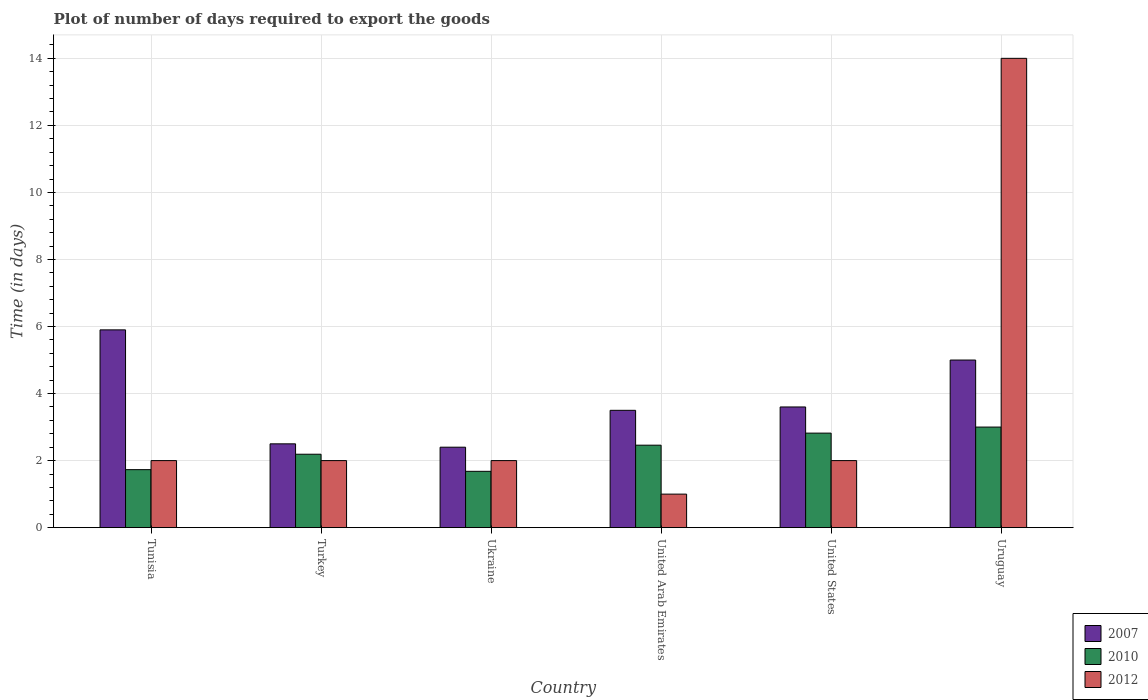How many groups of bars are there?
Offer a terse response. 6. Are the number of bars per tick equal to the number of legend labels?
Keep it short and to the point. Yes. Are the number of bars on each tick of the X-axis equal?
Your response must be concise. Yes. How many bars are there on the 4th tick from the left?
Provide a succinct answer. 3. How many bars are there on the 4th tick from the right?
Provide a succinct answer. 3. What is the label of the 4th group of bars from the left?
Give a very brief answer. United Arab Emirates. In how many cases, is the number of bars for a given country not equal to the number of legend labels?
Your answer should be compact. 0. What is the time required to export goods in 2010 in United States?
Offer a terse response. 2.82. Across all countries, what is the maximum time required to export goods in 2012?
Your answer should be compact. 14. Across all countries, what is the minimum time required to export goods in 2010?
Provide a short and direct response. 1.68. In which country was the time required to export goods in 2007 maximum?
Keep it short and to the point. Tunisia. In which country was the time required to export goods in 2010 minimum?
Offer a terse response. Ukraine. What is the total time required to export goods in 2010 in the graph?
Your answer should be very brief. 13.88. What is the difference between the time required to export goods in 2010 in Ukraine and that in United Arab Emirates?
Keep it short and to the point. -0.78. What is the difference between the time required to export goods in 2010 in Tunisia and the time required to export goods in 2012 in United States?
Your answer should be compact. -0.27. What is the average time required to export goods in 2012 per country?
Make the answer very short. 3.83. What is the difference between the time required to export goods of/in 2007 and time required to export goods of/in 2012 in Ukraine?
Provide a succinct answer. 0.4. What is the ratio of the time required to export goods in 2012 in Ukraine to that in United Arab Emirates?
Your response must be concise. 2. Is the difference between the time required to export goods in 2007 in Tunisia and Turkey greater than the difference between the time required to export goods in 2012 in Tunisia and Turkey?
Provide a succinct answer. Yes. What is the difference between the highest and the lowest time required to export goods in 2007?
Keep it short and to the point. 3.5. In how many countries, is the time required to export goods in 2010 greater than the average time required to export goods in 2010 taken over all countries?
Provide a succinct answer. 3. Is the sum of the time required to export goods in 2012 in Tunisia and United States greater than the maximum time required to export goods in 2007 across all countries?
Give a very brief answer. No. What does the 3rd bar from the left in United States represents?
Keep it short and to the point. 2012. Is it the case that in every country, the sum of the time required to export goods in 2010 and time required to export goods in 2012 is greater than the time required to export goods in 2007?
Provide a succinct answer. No. Are all the bars in the graph horizontal?
Keep it short and to the point. No. What is the difference between two consecutive major ticks on the Y-axis?
Your answer should be compact. 2. Are the values on the major ticks of Y-axis written in scientific E-notation?
Your response must be concise. No. Does the graph contain any zero values?
Offer a terse response. No. Does the graph contain grids?
Your answer should be compact. Yes. Where does the legend appear in the graph?
Your answer should be very brief. Bottom right. How many legend labels are there?
Make the answer very short. 3. How are the legend labels stacked?
Provide a short and direct response. Vertical. What is the title of the graph?
Ensure brevity in your answer.  Plot of number of days required to export the goods. What is the label or title of the X-axis?
Offer a very short reply. Country. What is the label or title of the Y-axis?
Offer a very short reply. Time (in days). What is the Time (in days) in 2010 in Tunisia?
Offer a very short reply. 1.73. What is the Time (in days) of 2010 in Turkey?
Provide a short and direct response. 2.19. What is the Time (in days) in 2012 in Turkey?
Give a very brief answer. 2. What is the Time (in days) in 2010 in Ukraine?
Give a very brief answer. 1.68. What is the Time (in days) in 2012 in Ukraine?
Keep it short and to the point. 2. What is the Time (in days) in 2010 in United Arab Emirates?
Keep it short and to the point. 2.46. What is the Time (in days) of 2012 in United Arab Emirates?
Make the answer very short. 1. What is the Time (in days) of 2010 in United States?
Your response must be concise. 2.82. What is the Time (in days) in 2007 in Uruguay?
Your answer should be compact. 5. What is the Time (in days) of 2010 in Uruguay?
Keep it short and to the point. 3. Across all countries, what is the maximum Time (in days) of 2010?
Your answer should be very brief. 3. Across all countries, what is the maximum Time (in days) of 2012?
Your response must be concise. 14. Across all countries, what is the minimum Time (in days) in 2007?
Give a very brief answer. 2.4. Across all countries, what is the minimum Time (in days) in 2010?
Provide a succinct answer. 1.68. What is the total Time (in days) in 2007 in the graph?
Keep it short and to the point. 22.9. What is the total Time (in days) in 2010 in the graph?
Make the answer very short. 13.88. What is the difference between the Time (in days) in 2010 in Tunisia and that in Turkey?
Ensure brevity in your answer.  -0.46. What is the difference between the Time (in days) of 2012 in Tunisia and that in Turkey?
Give a very brief answer. 0. What is the difference between the Time (in days) in 2007 in Tunisia and that in Ukraine?
Your answer should be very brief. 3.5. What is the difference between the Time (in days) of 2010 in Tunisia and that in Ukraine?
Give a very brief answer. 0.05. What is the difference between the Time (in days) of 2007 in Tunisia and that in United Arab Emirates?
Offer a very short reply. 2.4. What is the difference between the Time (in days) in 2010 in Tunisia and that in United Arab Emirates?
Keep it short and to the point. -0.73. What is the difference between the Time (in days) in 2010 in Tunisia and that in United States?
Your answer should be compact. -1.09. What is the difference between the Time (in days) of 2012 in Tunisia and that in United States?
Provide a succinct answer. 0. What is the difference between the Time (in days) in 2007 in Tunisia and that in Uruguay?
Your response must be concise. 0.9. What is the difference between the Time (in days) in 2010 in Tunisia and that in Uruguay?
Your answer should be compact. -1.27. What is the difference between the Time (in days) of 2007 in Turkey and that in Ukraine?
Offer a very short reply. 0.1. What is the difference between the Time (in days) of 2010 in Turkey and that in Ukraine?
Your answer should be very brief. 0.51. What is the difference between the Time (in days) of 2010 in Turkey and that in United Arab Emirates?
Your answer should be compact. -0.27. What is the difference between the Time (in days) in 2012 in Turkey and that in United Arab Emirates?
Provide a succinct answer. 1. What is the difference between the Time (in days) in 2007 in Turkey and that in United States?
Offer a terse response. -1.1. What is the difference between the Time (in days) in 2010 in Turkey and that in United States?
Ensure brevity in your answer.  -0.63. What is the difference between the Time (in days) in 2012 in Turkey and that in United States?
Offer a very short reply. 0. What is the difference between the Time (in days) of 2007 in Turkey and that in Uruguay?
Give a very brief answer. -2.5. What is the difference between the Time (in days) of 2010 in Turkey and that in Uruguay?
Offer a very short reply. -0.81. What is the difference between the Time (in days) in 2010 in Ukraine and that in United Arab Emirates?
Make the answer very short. -0.78. What is the difference between the Time (in days) of 2012 in Ukraine and that in United Arab Emirates?
Provide a succinct answer. 1. What is the difference between the Time (in days) of 2010 in Ukraine and that in United States?
Offer a terse response. -1.14. What is the difference between the Time (in days) in 2007 in Ukraine and that in Uruguay?
Your answer should be very brief. -2.6. What is the difference between the Time (in days) of 2010 in Ukraine and that in Uruguay?
Your response must be concise. -1.32. What is the difference between the Time (in days) of 2007 in United Arab Emirates and that in United States?
Provide a succinct answer. -0.1. What is the difference between the Time (in days) of 2010 in United Arab Emirates and that in United States?
Offer a very short reply. -0.36. What is the difference between the Time (in days) of 2010 in United Arab Emirates and that in Uruguay?
Your answer should be compact. -0.54. What is the difference between the Time (in days) in 2012 in United Arab Emirates and that in Uruguay?
Give a very brief answer. -13. What is the difference between the Time (in days) of 2010 in United States and that in Uruguay?
Ensure brevity in your answer.  -0.18. What is the difference between the Time (in days) of 2012 in United States and that in Uruguay?
Give a very brief answer. -12. What is the difference between the Time (in days) of 2007 in Tunisia and the Time (in days) of 2010 in Turkey?
Provide a short and direct response. 3.71. What is the difference between the Time (in days) in 2010 in Tunisia and the Time (in days) in 2012 in Turkey?
Your answer should be very brief. -0.27. What is the difference between the Time (in days) of 2007 in Tunisia and the Time (in days) of 2010 in Ukraine?
Make the answer very short. 4.22. What is the difference between the Time (in days) of 2010 in Tunisia and the Time (in days) of 2012 in Ukraine?
Make the answer very short. -0.27. What is the difference between the Time (in days) in 2007 in Tunisia and the Time (in days) in 2010 in United Arab Emirates?
Your answer should be compact. 3.44. What is the difference between the Time (in days) of 2010 in Tunisia and the Time (in days) of 2012 in United Arab Emirates?
Your response must be concise. 0.73. What is the difference between the Time (in days) of 2007 in Tunisia and the Time (in days) of 2010 in United States?
Your answer should be compact. 3.08. What is the difference between the Time (in days) in 2010 in Tunisia and the Time (in days) in 2012 in United States?
Ensure brevity in your answer.  -0.27. What is the difference between the Time (in days) in 2007 in Tunisia and the Time (in days) in 2010 in Uruguay?
Provide a succinct answer. 2.9. What is the difference between the Time (in days) of 2007 in Tunisia and the Time (in days) of 2012 in Uruguay?
Offer a terse response. -8.1. What is the difference between the Time (in days) in 2010 in Tunisia and the Time (in days) in 2012 in Uruguay?
Provide a succinct answer. -12.27. What is the difference between the Time (in days) in 2007 in Turkey and the Time (in days) in 2010 in Ukraine?
Offer a very short reply. 0.82. What is the difference between the Time (in days) of 2007 in Turkey and the Time (in days) of 2012 in Ukraine?
Give a very brief answer. 0.5. What is the difference between the Time (in days) of 2010 in Turkey and the Time (in days) of 2012 in Ukraine?
Your response must be concise. 0.19. What is the difference between the Time (in days) in 2010 in Turkey and the Time (in days) in 2012 in United Arab Emirates?
Provide a succinct answer. 1.19. What is the difference between the Time (in days) in 2007 in Turkey and the Time (in days) in 2010 in United States?
Offer a terse response. -0.32. What is the difference between the Time (in days) of 2007 in Turkey and the Time (in days) of 2012 in United States?
Your answer should be compact. 0.5. What is the difference between the Time (in days) of 2010 in Turkey and the Time (in days) of 2012 in United States?
Offer a very short reply. 0.19. What is the difference between the Time (in days) in 2010 in Turkey and the Time (in days) in 2012 in Uruguay?
Make the answer very short. -11.81. What is the difference between the Time (in days) in 2007 in Ukraine and the Time (in days) in 2010 in United Arab Emirates?
Make the answer very short. -0.06. What is the difference between the Time (in days) of 2007 in Ukraine and the Time (in days) of 2012 in United Arab Emirates?
Offer a terse response. 1.4. What is the difference between the Time (in days) of 2010 in Ukraine and the Time (in days) of 2012 in United Arab Emirates?
Make the answer very short. 0.68. What is the difference between the Time (in days) of 2007 in Ukraine and the Time (in days) of 2010 in United States?
Provide a short and direct response. -0.42. What is the difference between the Time (in days) in 2007 in Ukraine and the Time (in days) in 2012 in United States?
Your response must be concise. 0.4. What is the difference between the Time (in days) in 2010 in Ukraine and the Time (in days) in 2012 in United States?
Ensure brevity in your answer.  -0.32. What is the difference between the Time (in days) in 2010 in Ukraine and the Time (in days) in 2012 in Uruguay?
Your answer should be very brief. -12.32. What is the difference between the Time (in days) of 2007 in United Arab Emirates and the Time (in days) of 2010 in United States?
Your answer should be very brief. 0.68. What is the difference between the Time (in days) of 2007 in United Arab Emirates and the Time (in days) of 2012 in United States?
Keep it short and to the point. 1.5. What is the difference between the Time (in days) of 2010 in United Arab Emirates and the Time (in days) of 2012 in United States?
Give a very brief answer. 0.46. What is the difference between the Time (in days) of 2007 in United Arab Emirates and the Time (in days) of 2010 in Uruguay?
Provide a succinct answer. 0.5. What is the difference between the Time (in days) in 2007 in United Arab Emirates and the Time (in days) in 2012 in Uruguay?
Provide a short and direct response. -10.5. What is the difference between the Time (in days) in 2010 in United Arab Emirates and the Time (in days) in 2012 in Uruguay?
Offer a terse response. -11.54. What is the difference between the Time (in days) of 2007 in United States and the Time (in days) of 2012 in Uruguay?
Provide a succinct answer. -10.4. What is the difference between the Time (in days) in 2010 in United States and the Time (in days) in 2012 in Uruguay?
Your answer should be very brief. -11.18. What is the average Time (in days) of 2007 per country?
Your answer should be very brief. 3.82. What is the average Time (in days) of 2010 per country?
Offer a terse response. 2.31. What is the average Time (in days) of 2012 per country?
Keep it short and to the point. 3.83. What is the difference between the Time (in days) in 2007 and Time (in days) in 2010 in Tunisia?
Give a very brief answer. 4.17. What is the difference between the Time (in days) in 2007 and Time (in days) in 2012 in Tunisia?
Give a very brief answer. 3.9. What is the difference between the Time (in days) in 2010 and Time (in days) in 2012 in Tunisia?
Give a very brief answer. -0.27. What is the difference between the Time (in days) in 2007 and Time (in days) in 2010 in Turkey?
Ensure brevity in your answer.  0.31. What is the difference between the Time (in days) of 2010 and Time (in days) of 2012 in Turkey?
Offer a very short reply. 0.19. What is the difference between the Time (in days) of 2007 and Time (in days) of 2010 in Ukraine?
Provide a succinct answer. 0.72. What is the difference between the Time (in days) in 2007 and Time (in days) in 2012 in Ukraine?
Make the answer very short. 0.4. What is the difference between the Time (in days) of 2010 and Time (in days) of 2012 in Ukraine?
Make the answer very short. -0.32. What is the difference between the Time (in days) in 2010 and Time (in days) in 2012 in United Arab Emirates?
Give a very brief answer. 1.46. What is the difference between the Time (in days) of 2007 and Time (in days) of 2010 in United States?
Provide a short and direct response. 0.78. What is the difference between the Time (in days) in 2010 and Time (in days) in 2012 in United States?
Your response must be concise. 0.82. What is the difference between the Time (in days) of 2007 and Time (in days) of 2012 in Uruguay?
Provide a short and direct response. -9. What is the difference between the Time (in days) of 2010 and Time (in days) of 2012 in Uruguay?
Give a very brief answer. -11. What is the ratio of the Time (in days) of 2007 in Tunisia to that in Turkey?
Your answer should be compact. 2.36. What is the ratio of the Time (in days) of 2010 in Tunisia to that in Turkey?
Provide a succinct answer. 0.79. What is the ratio of the Time (in days) in 2007 in Tunisia to that in Ukraine?
Offer a very short reply. 2.46. What is the ratio of the Time (in days) in 2010 in Tunisia to that in Ukraine?
Offer a very short reply. 1.03. What is the ratio of the Time (in days) in 2007 in Tunisia to that in United Arab Emirates?
Keep it short and to the point. 1.69. What is the ratio of the Time (in days) in 2010 in Tunisia to that in United Arab Emirates?
Make the answer very short. 0.7. What is the ratio of the Time (in days) of 2007 in Tunisia to that in United States?
Your response must be concise. 1.64. What is the ratio of the Time (in days) of 2010 in Tunisia to that in United States?
Provide a short and direct response. 0.61. What is the ratio of the Time (in days) in 2007 in Tunisia to that in Uruguay?
Provide a short and direct response. 1.18. What is the ratio of the Time (in days) of 2010 in Tunisia to that in Uruguay?
Make the answer very short. 0.58. What is the ratio of the Time (in days) in 2012 in Tunisia to that in Uruguay?
Offer a very short reply. 0.14. What is the ratio of the Time (in days) of 2007 in Turkey to that in Ukraine?
Provide a succinct answer. 1.04. What is the ratio of the Time (in days) of 2010 in Turkey to that in Ukraine?
Provide a succinct answer. 1.3. What is the ratio of the Time (in days) in 2010 in Turkey to that in United Arab Emirates?
Your answer should be compact. 0.89. What is the ratio of the Time (in days) in 2007 in Turkey to that in United States?
Your answer should be very brief. 0.69. What is the ratio of the Time (in days) in 2010 in Turkey to that in United States?
Provide a succinct answer. 0.78. What is the ratio of the Time (in days) of 2012 in Turkey to that in United States?
Make the answer very short. 1. What is the ratio of the Time (in days) in 2007 in Turkey to that in Uruguay?
Offer a terse response. 0.5. What is the ratio of the Time (in days) in 2010 in Turkey to that in Uruguay?
Offer a terse response. 0.73. What is the ratio of the Time (in days) in 2012 in Turkey to that in Uruguay?
Provide a short and direct response. 0.14. What is the ratio of the Time (in days) in 2007 in Ukraine to that in United Arab Emirates?
Your answer should be very brief. 0.69. What is the ratio of the Time (in days) in 2010 in Ukraine to that in United Arab Emirates?
Ensure brevity in your answer.  0.68. What is the ratio of the Time (in days) in 2010 in Ukraine to that in United States?
Your answer should be compact. 0.6. What is the ratio of the Time (in days) in 2007 in Ukraine to that in Uruguay?
Keep it short and to the point. 0.48. What is the ratio of the Time (in days) in 2010 in Ukraine to that in Uruguay?
Give a very brief answer. 0.56. What is the ratio of the Time (in days) of 2012 in Ukraine to that in Uruguay?
Make the answer very short. 0.14. What is the ratio of the Time (in days) of 2007 in United Arab Emirates to that in United States?
Your answer should be very brief. 0.97. What is the ratio of the Time (in days) in 2010 in United Arab Emirates to that in United States?
Your answer should be very brief. 0.87. What is the ratio of the Time (in days) in 2012 in United Arab Emirates to that in United States?
Provide a short and direct response. 0.5. What is the ratio of the Time (in days) in 2010 in United Arab Emirates to that in Uruguay?
Provide a short and direct response. 0.82. What is the ratio of the Time (in days) in 2012 in United Arab Emirates to that in Uruguay?
Make the answer very short. 0.07. What is the ratio of the Time (in days) in 2007 in United States to that in Uruguay?
Your answer should be very brief. 0.72. What is the ratio of the Time (in days) in 2012 in United States to that in Uruguay?
Make the answer very short. 0.14. What is the difference between the highest and the second highest Time (in days) in 2007?
Ensure brevity in your answer.  0.9. What is the difference between the highest and the second highest Time (in days) in 2010?
Make the answer very short. 0.18. What is the difference between the highest and the second highest Time (in days) of 2012?
Make the answer very short. 12. What is the difference between the highest and the lowest Time (in days) of 2010?
Your answer should be very brief. 1.32. 